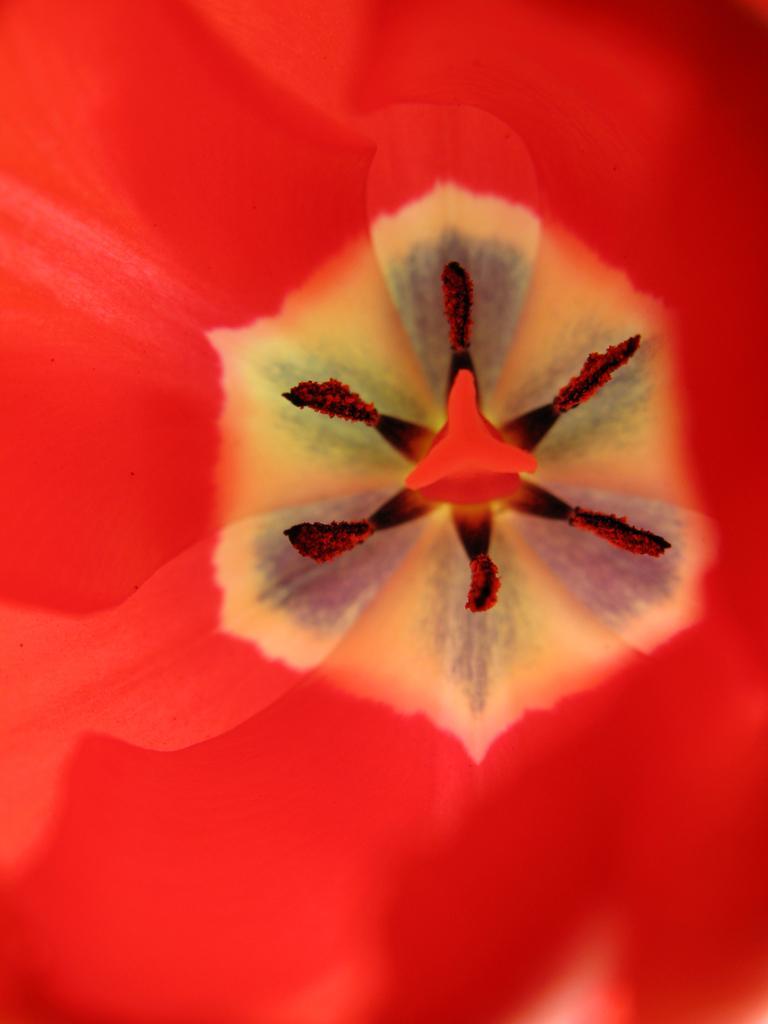Describe this image in one or two sentences. In this picture we can see a flower. 